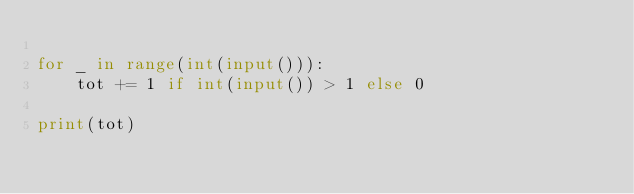<code> <loc_0><loc_0><loc_500><loc_500><_Python_>
for _ in range(int(input())):
    tot += 1 if int(input()) > 1 else 0

print(tot)</code> 